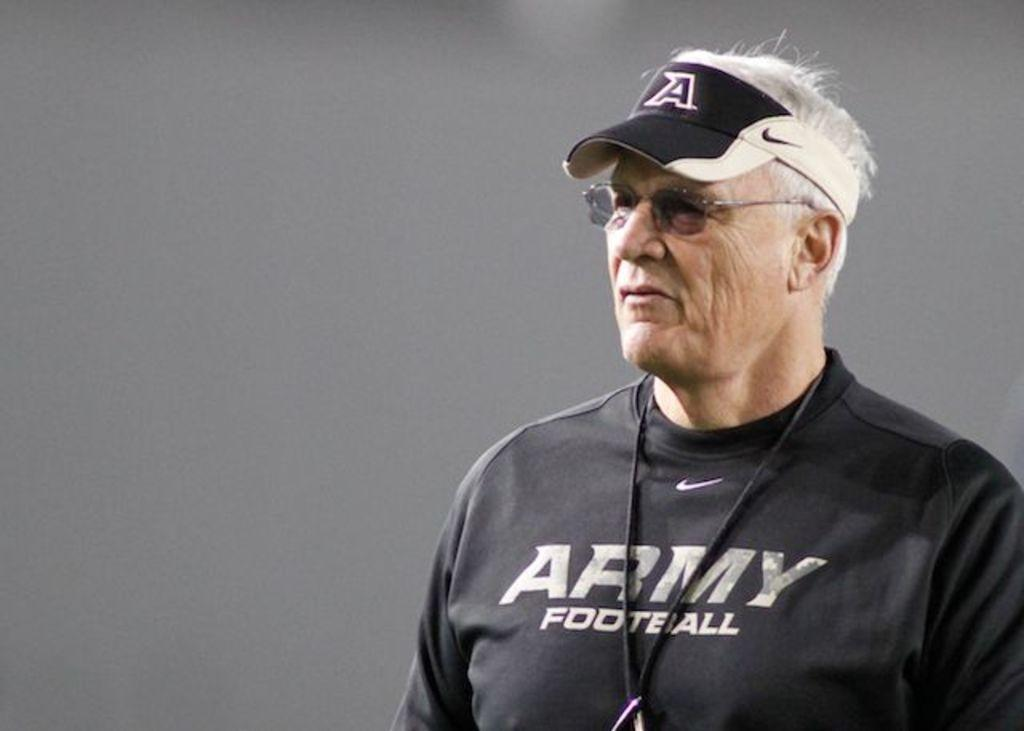<image>
Create a compact narrative representing the image presented. a white male wearing a nike cap and a black shirt 